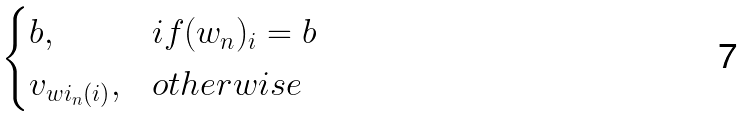Convert formula to latex. <formula><loc_0><loc_0><loc_500><loc_500>\begin{cases} b , & i f ( w _ { n } ) _ { i } = b \\ v _ { w i _ { n } ( i ) } , & o t h e r w i s e \end{cases}</formula> 